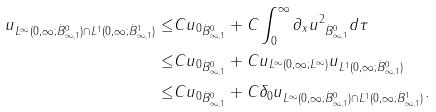Convert formula to latex. <formula><loc_0><loc_0><loc_500><loc_500>\| u \| _ { L ^ { \infty } ( 0 , \infty ; \dot { B } ^ { 0 } _ { \infty , 1 } ) \cap L ^ { 1 } ( 0 , \infty ; \dot { B } ^ { 1 } _ { \infty , 1 } ) } \leq & C \| u _ { 0 } \| _ { \dot { B } ^ { 0 } _ { \infty , 1 } } + C \int _ { 0 } ^ { \infty } \| \partial _ { x } u ^ { 2 } \| _ { \dot { B } ^ { 0 } _ { \infty , 1 } } d \tau \\ \leq & C \| u _ { 0 } \| _ { \dot { B } ^ { 0 } _ { \infty , 1 } } + C \| u \| _ { L ^ { \infty } ( 0 , \infty ; L ^ { \infty } ) } \| u \| _ { L ^ { 1 } ( 0 , \infty ; \dot { B } ^ { 0 } _ { \infty , 1 } ) } \\ \leq & C \| u _ { 0 } \| _ { \dot { B } ^ { 0 } _ { \infty , 1 } } + C \delta _ { 0 } \| u \| _ { L ^ { \infty } ( 0 , \infty ; \dot { B } ^ { 0 } _ { \infty , 1 } ) \cap L ^ { 1 } ( 0 , \infty ; \dot { B } ^ { 1 } _ { \infty , 1 } ) } .</formula> 